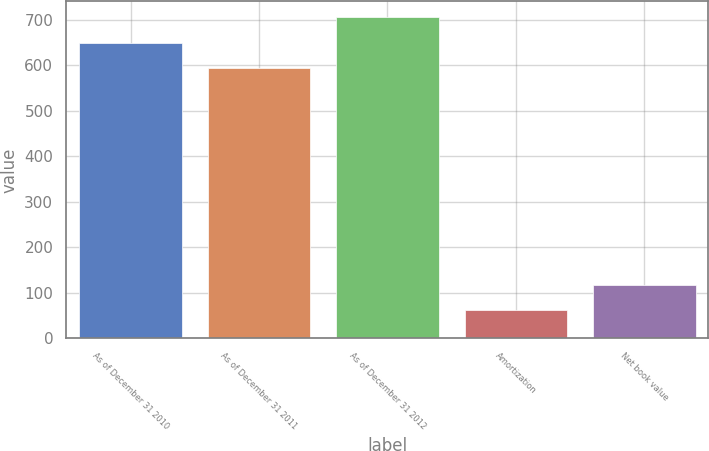<chart> <loc_0><loc_0><loc_500><loc_500><bar_chart><fcel>As of December 31 2010<fcel>As of December 31 2011<fcel>As of December 31 2012<fcel>Amortization<fcel>Net book value<nl><fcel>649.3<fcel>594<fcel>704.6<fcel>62<fcel>117.3<nl></chart> 